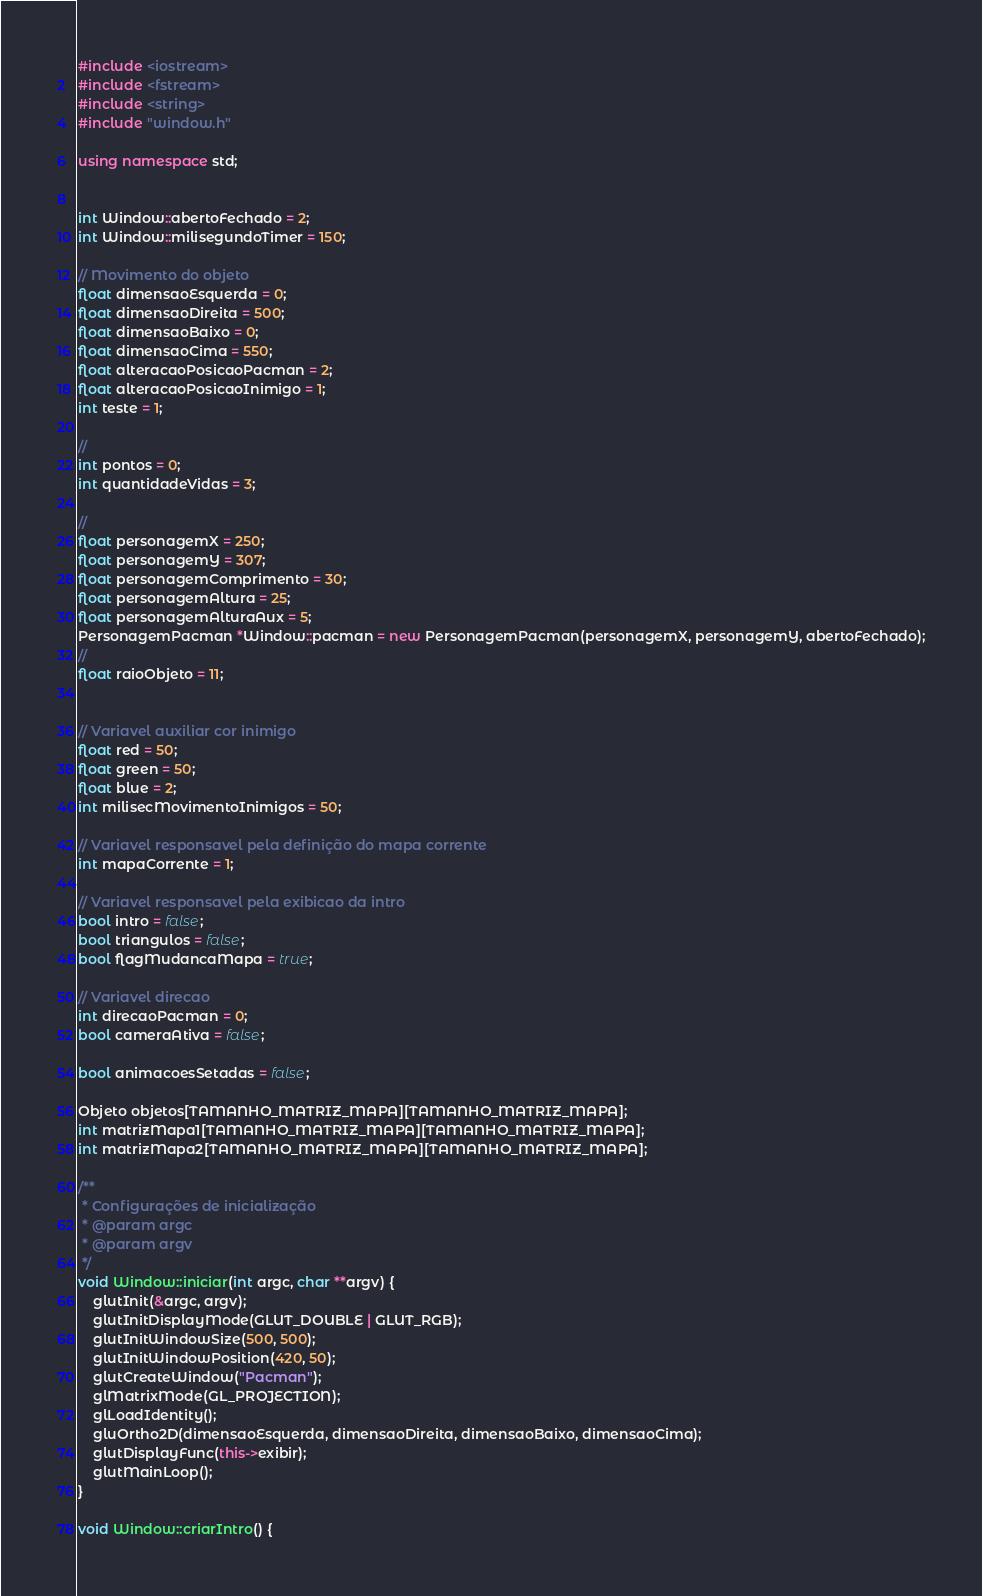Convert code to text. <code><loc_0><loc_0><loc_500><loc_500><_C++_>#include <iostream>
#include <fstream>
#include <string>
#include "window.h"

using namespace std;


int Window::abertoFechado = 2;
int Window::milisegundoTimer = 150;

// Movimento do objeto
float dimensaoEsquerda = 0;
float dimensaoDireita = 500;
float dimensaoBaixo = 0;
float dimensaoCima = 550;
float alteracaoPosicaoPacman = 2;
float alteracaoPosicaoInimigo = 1;
int teste = 1;

//
int pontos = 0;
int quantidadeVidas = 3;

//
float personagemX = 250;
float personagemY = 307;
float personagemComprimento = 30;
float personagemAltura = 25;
float personagemAlturaAux = 5;
PersonagemPacman *Window::pacman = new PersonagemPacman(personagemX, personagemY, abertoFechado);
//
float raioObjeto = 11;


// Variavel auxiliar cor inimigo
float red = 50;
float green = 50;
float blue = 2;
int milisecMovimentoInimigos = 50;

// Variavel responsavel pela definição do mapa corrente
int mapaCorrente = 1;

// Variavel responsavel pela exibicao da intro
bool intro = false;
bool triangulos = false;
bool flagMudancaMapa = true;

// Variavel direcao
int direcaoPacman = 0;
bool cameraAtiva = false;

bool animacoesSetadas = false;

Objeto objetos[TAMANHO_MATRIZ_MAPA][TAMANHO_MATRIZ_MAPA];
int matrizMapa1[TAMANHO_MATRIZ_MAPA][TAMANHO_MATRIZ_MAPA];
int matrizMapa2[TAMANHO_MATRIZ_MAPA][TAMANHO_MATRIZ_MAPA];

/**
 * Configurações de inicialização
 * @param argc
 * @param argv
 */
void Window::iniciar(int argc, char **argv) {
    glutInit(&argc, argv);
    glutInitDisplayMode(GLUT_DOUBLE | GLUT_RGB);
    glutInitWindowSize(500, 500);
    glutInitWindowPosition(420, 50);
    glutCreateWindow("Pacman");
    glMatrixMode(GL_PROJECTION);
    glLoadIdentity();
    gluOrtho2D(dimensaoEsquerda, dimensaoDireita, dimensaoBaixo, dimensaoCima);
    glutDisplayFunc(this->exibir);
    glutMainLoop();
}

void Window::criarIntro() {</code> 